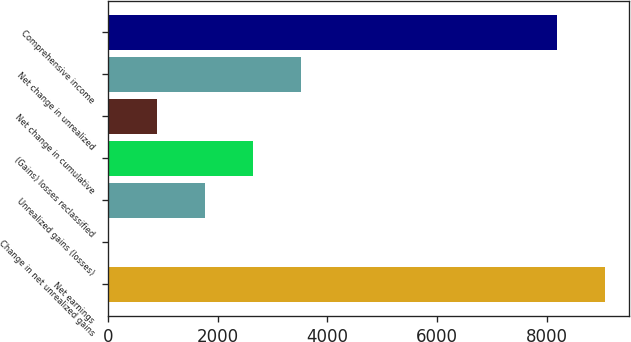Convert chart. <chart><loc_0><loc_0><loc_500><loc_500><bar_chart><fcel>Net earnings<fcel>Change in net unrealized gains<fcel>Unrealized gains (losses)<fcel>(Gains) losses reclassified<fcel>Net change in cumulative<fcel>Net change in unrealized<fcel>Comprehensive income<nl><fcel>9045.5<fcel>16<fcel>1765<fcel>2639.5<fcel>890.5<fcel>3514<fcel>8171<nl></chart> 